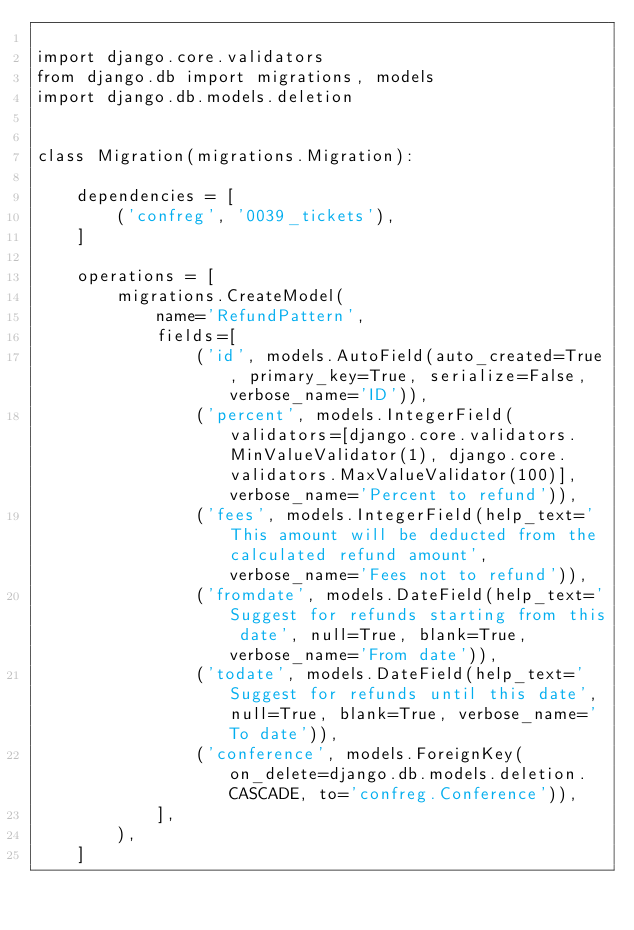Convert code to text. <code><loc_0><loc_0><loc_500><loc_500><_Python_>
import django.core.validators
from django.db import migrations, models
import django.db.models.deletion


class Migration(migrations.Migration):

    dependencies = [
        ('confreg', '0039_tickets'),
    ]

    operations = [
        migrations.CreateModel(
            name='RefundPattern',
            fields=[
                ('id', models.AutoField(auto_created=True, primary_key=True, serialize=False, verbose_name='ID')),
                ('percent', models.IntegerField(validators=[django.core.validators.MinValueValidator(1), django.core.validators.MaxValueValidator(100)], verbose_name='Percent to refund')),
                ('fees', models.IntegerField(help_text='This amount will be deducted from the calculated refund amount', verbose_name='Fees not to refund')),
                ('fromdate', models.DateField(help_text='Suggest for refunds starting from this date', null=True, blank=True, verbose_name='From date')),
                ('todate', models.DateField(help_text='Suggest for refunds until this date', null=True, blank=True, verbose_name='To date')),
                ('conference', models.ForeignKey(on_delete=django.db.models.deletion.CASCADE, to='confreg.Conference')),
            ],
        ),
    ]
</code> 